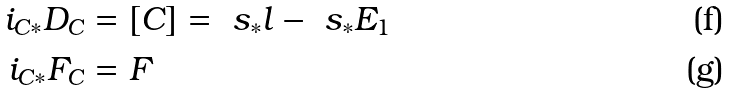<formula> <loc_0><loc_0><loc_500><loc_500>i _ { C * } D _ { C } & = [ C ] = \ s _ { * } l - \ s _ { * } E _ { 1 } \\ i _ { C * } F _ { C } & = F</formula> 